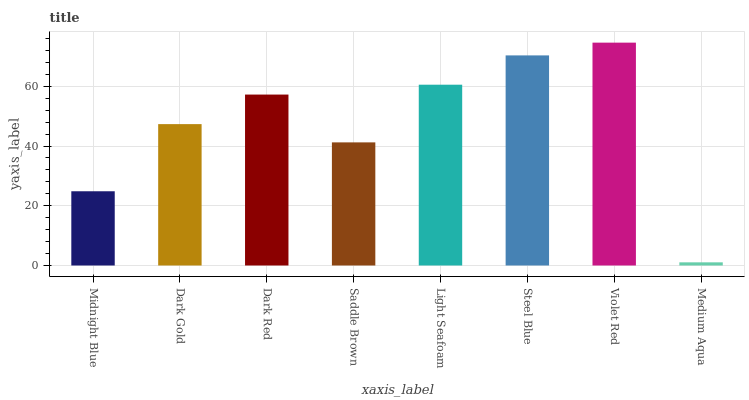Is Medium Aqua the minimum?
Answer yes or no. Yes. Is Violet Red the maximum?
Answer yes or no. Yes. Is Dark Gold the minimum?
Answer yes or no. No. Is Dark Gold the maximum?
Answer yes or no. No. Is Dark Gold greater than Midnight Blue?
Answer yes or no. Yes. Is Midnight Blue less than Dark Gold?
Answer yes or no. Yes. Is Midnight Blue greater than Dark Gold?
Answer yes or no. No. Is Dark Gold less than Midnight Blue?
Answer yes or no. No. Is Dark Red the high median?
Answer yes or no. Yes. Is Dark Gold the low median?
Answer yes or no. Yes. Is Light Seafoam the high median?
Answer yes or no. No. Is Light Seafoam the low median?
Answer yes or no. No. 